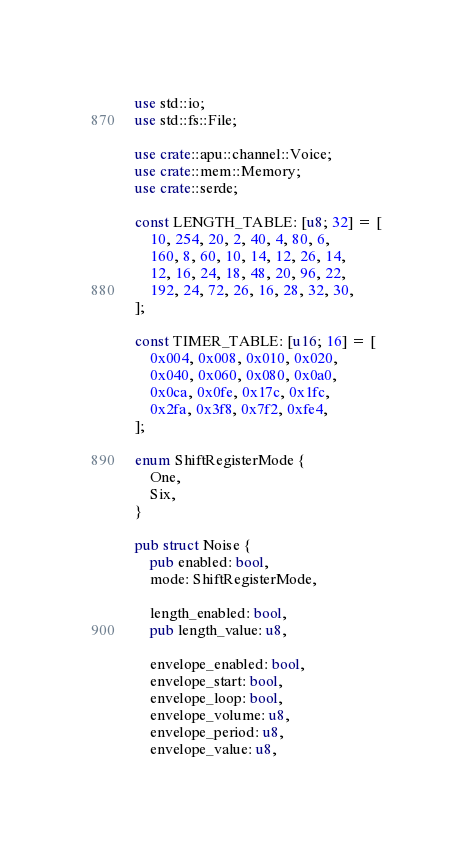<code> <loc_0><loc_0><loc_500><loc_500><_Rust_>use std::io;
use std::fs::File;

use crate::apu::channel::Voice;
use crate::mem::Memory;
use crate::serde;

const LENGTH_TABLE: [u8; 32] = [
    10, 254, 20, 2, 40, 4, 80, 6,
    160, 8, 60, 10, 14, 12, 26, 14,
    12, 16, 24, 18, 48, 20, 96, 22,
    192, 24, 72, 26, 16, 28, 32, 30,
];

const TIMER_TABLE: [u16; 16] = [
    0x004, 0x008, 0x010, 0x020,
    0x040, 0x060, 0x080, 0x0a0,
    0x0ca, 0x0fe, 0x17c, 0x1fc,
    0x2fa, 0x3f8, 0x7f2, 0xfe4,
];

enum ShiftRegisterMode {
    One,
    Six,
}

pub struct Noise {
    pub enabled: bool,
    mode: ShiftRegisterMode,

    length_enabled: bool,
    pub length_value: u8,

    envelope_enabled: bool,
    envelope_start: bool,
    envelope_loop: bool,
    envelope_volume: u8,
    envelope_period: u8,
    envelope_value: u8,</code> 